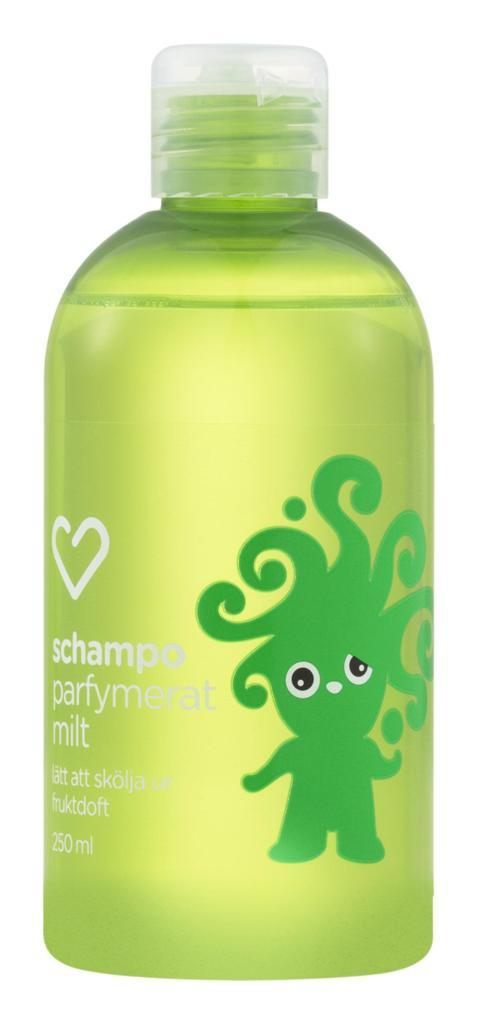<image>
Present a compact description of the photo's key features. A bottle of schampo parfymerat milt with a picture of a heart above the saying and a green character on the front of the bottle. 